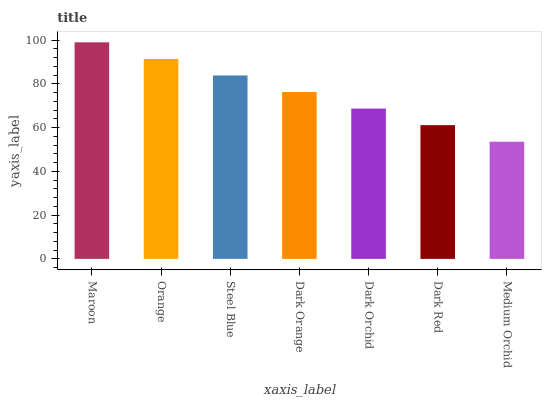Is Medium Orchid the minimum?
Answer yes or no. Yes. Is Maroon the maximum?
Answer yes or no. Yes. Is Orange the minimum?
Answer yes or no. No. Is Orange the maximum?
Answer yes or no. No. Is Maroon greater than Orange?
Answer yes or no. Yes. Is Orange less than Maroon?
Answer yes or no. Yes. Is Orange greater than Maroon?
Answer yes or no. No. Is Maroon less than Orange?
Answer yes or no. No. Is Dark Orange the high median?
Answer yes or no. Yes. Is Dark Orange the low median?
Answer yes or no. Yes. Is Medium Orchid the high median?
Answer yes or no. No. Is Orange the low median?
Answer yes or no. No. 